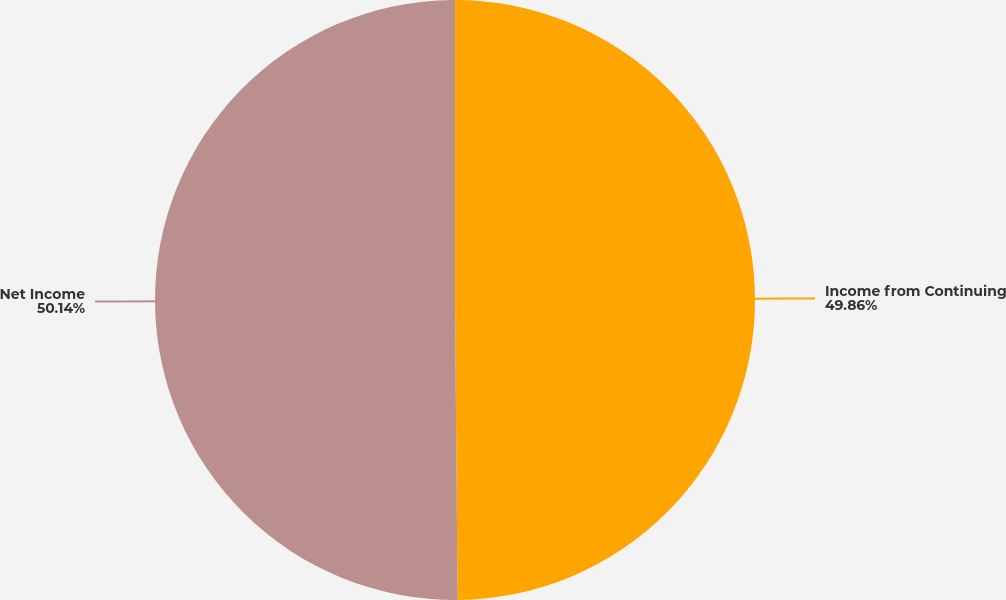<chart> <loc_0><loc_0><loc_500><loc_500><pie_chart><fcel>Income from Continuing<fcel>Net Income<nl><fcel>49.86%<fcel>50.14%<nl></chart> 